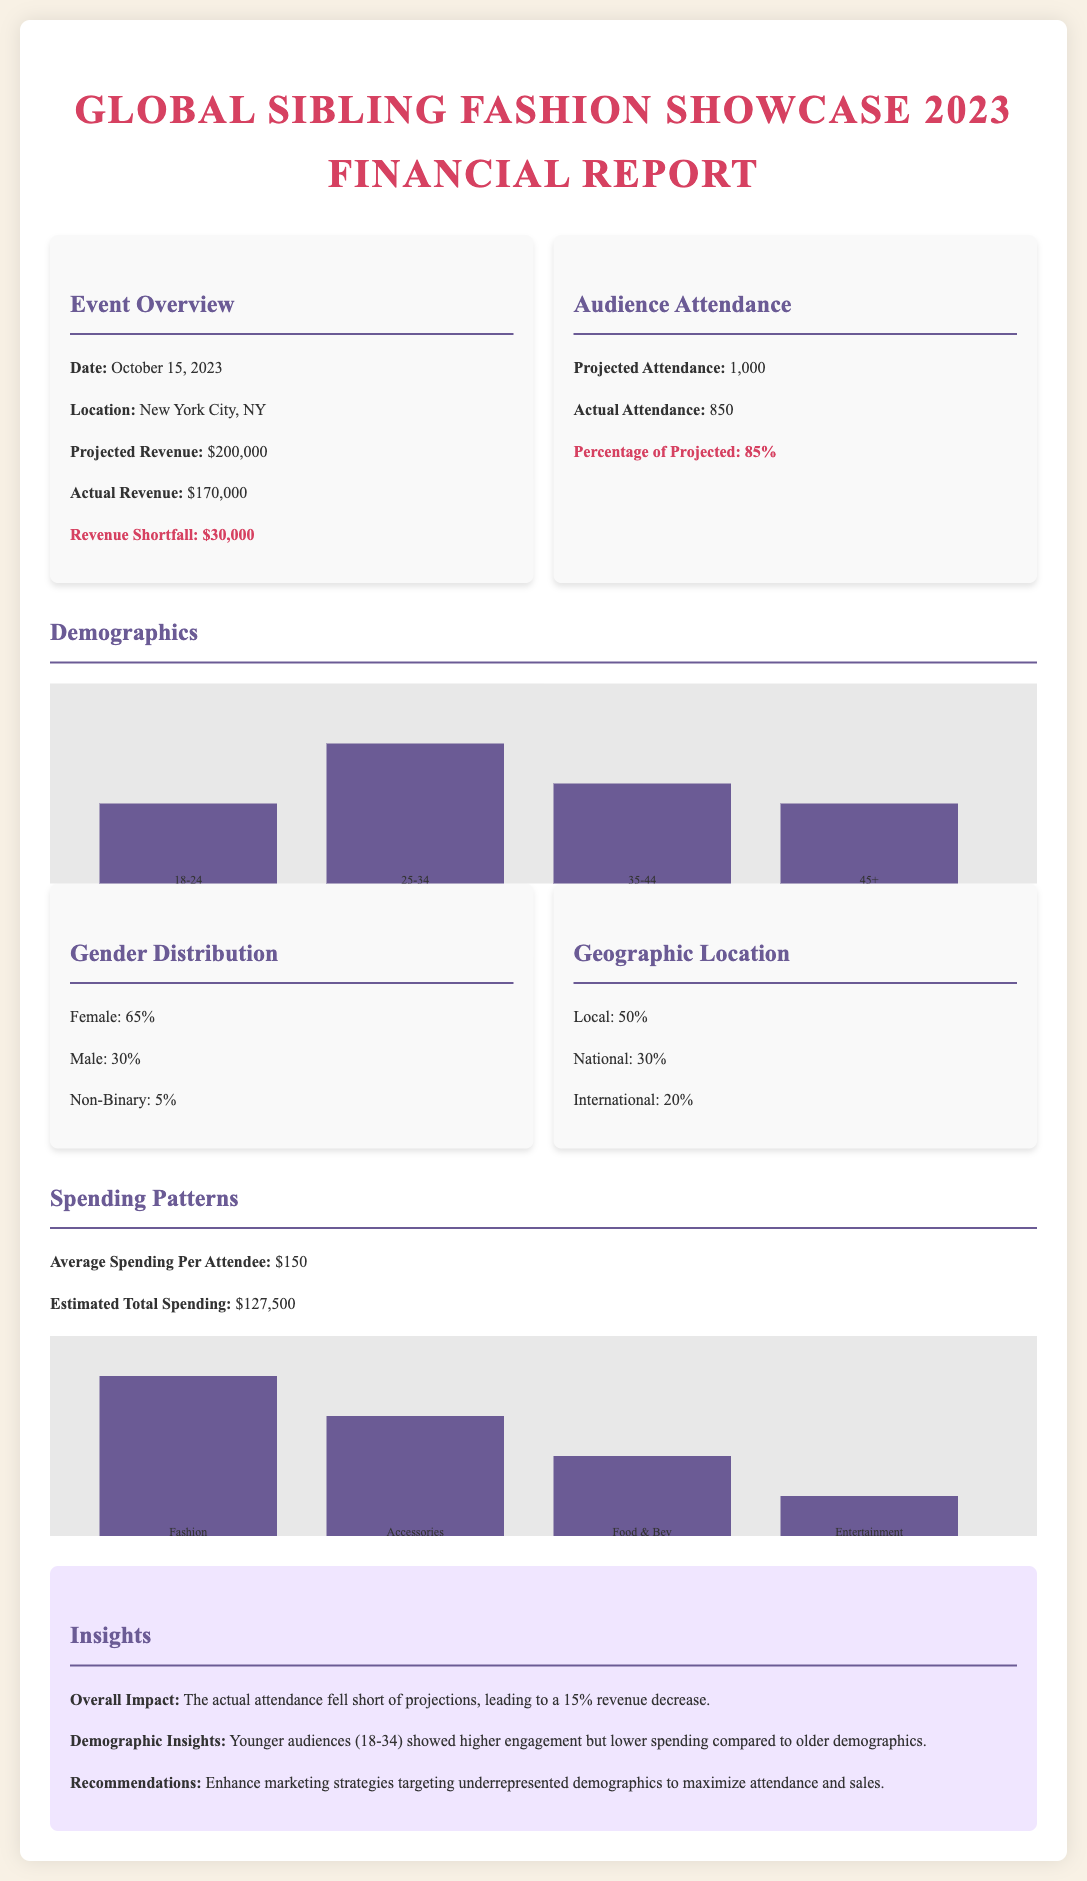What is the date of the event? The document states the event took place on October 15, 2023.
Answer: October 15, 2023 What was the projected revenue? The document lists the projected revenue as $200,000.
Answer: $200,000 What was the actual attendance percentage? The actual attendance percentage is mentioned as 85%.
Answer: 85% How much was the revenue shortfall? The revenue shortfall is identified in the document as $30,000.
Answer: $30,000 What is the percentage of audience aged 25-34? The demographics section notes that 35% of the audience is aged 25-34.
Answer: 35% What is the average spending per attendee? The average spending per attendee is stated to be $150.
Answer: $150 Which demographic showed the highest engagement? The document indicates that younger audiences (18-34) showed higher engagement.
Answer: Younger audiences (18-34) What was the estimated total spending? The estimated total spending is calculated as $127,500 based on the attendance and average spending.
Answer: $127,500 What percentage of attendees were Female? The gender distribution reveals that 65% of attendees were Female.
Answer: 65% 